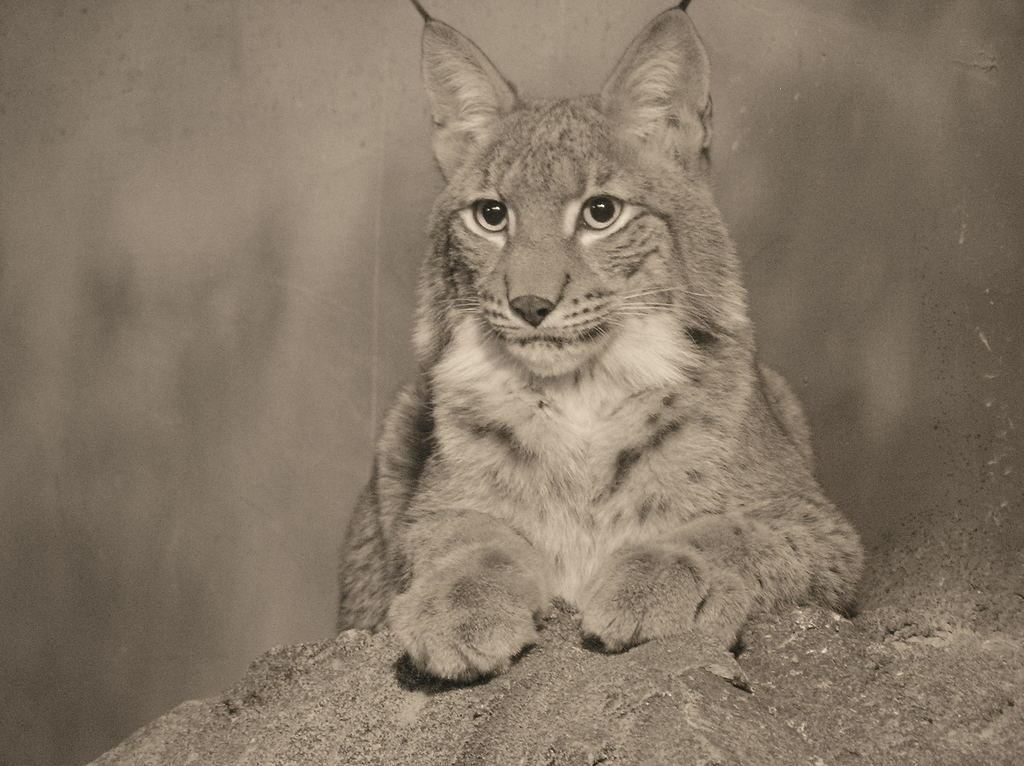What animal is in the image? There is a tiger in the image. Where is the tiger located? The tiger is on the ground. What type of rake is the tiger using in the image? There is no rake present in the image; the tiger is simply on the ground. 